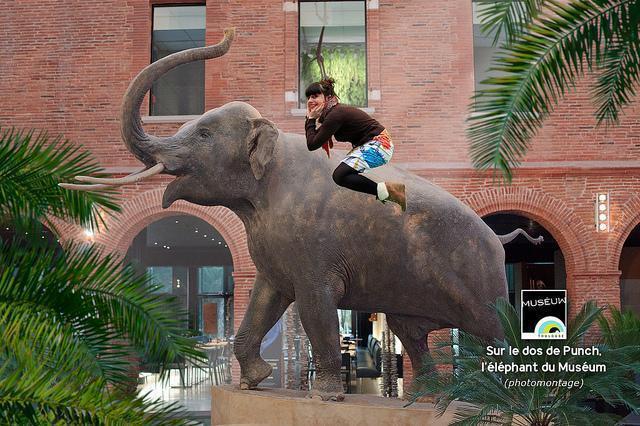What happened to this image?
Select the accurate response from the four choices given to answer the question.
Options: Blurred, photoshopped, too dark, too bright. Photoshopped. 